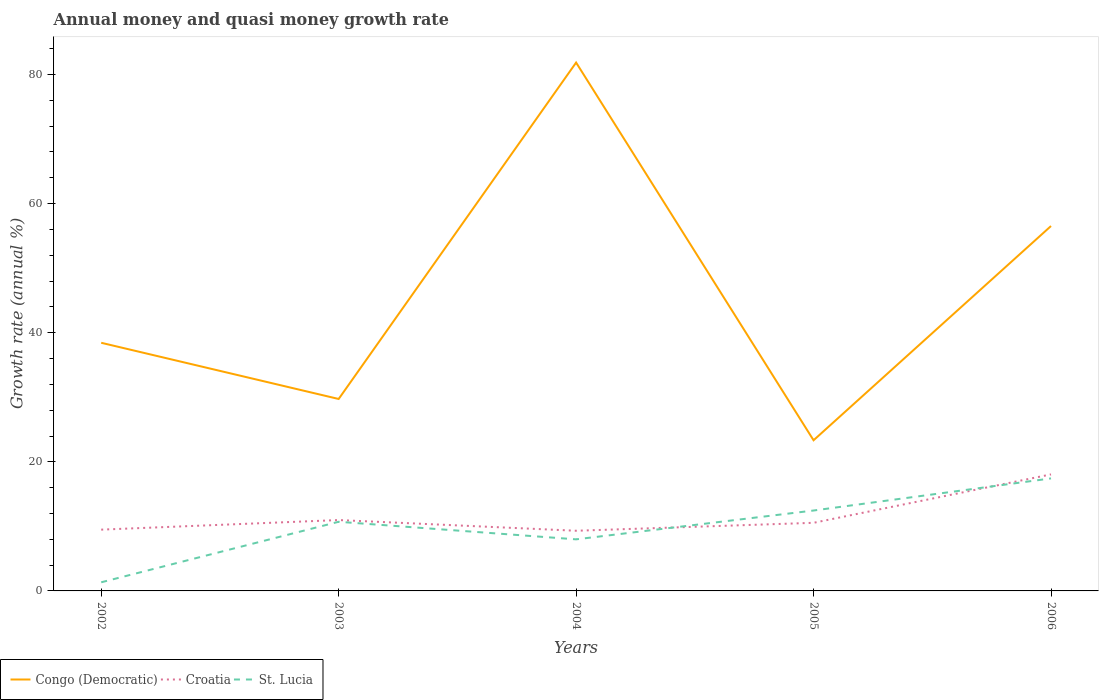How many different coloured lines are there?
Provide a short and direct response. 3. Does the line corresponding to Congo (Democratic) intersect with the line corresponding to St. Lucia?
Ensure brevity in your answer.  No. Is the number of lines equal to the number of legend labels?
Your answer should be compact. Yes. Across all years, what is the maximum growth rate in Croatia?
Offer a very short reply. 9.32. In which year was the growth rate in Congo (Democratic) maximum?
Provide a succinct answer. 2005. What is the total growth rate in St. Lucia in the graph?
Provide a short and direct response. 2.72. What is the difference between the highest and the second highest growth rate in Congo (Democratic)?
Provide a succinct answer. 58.51. What is the difference between the highest and the lowest growth rate in Congo (Democratic)?
Give a very brief answer. 2. Is the growth rate in Congo (Democratic) strictly greater than the growth rate in Croatia over the years?
Offer a terse response. No. What is the difference between two consecutive major ticks on the Y-axis?
Your answer should be compact. 20. Does the graph contain grids?
Keep it short and to the point. No. How many legend labels are there?
Your response must be concise. 3. How are the legend labels stacked?
Offer a very short reply. Horizontal. What is the title of the graph?
Your response must be concise. Annual money and quasi money growth rate. What is the label or title of the X-axis?
Keep it short and to the point. Years. What is the label or title of the Y-axis?
Give a very brief answer. Growth rate (annual %). What is the Growth rate (annual %) of Congo (Democratic) in 2002?
Your answer should be compact. 38.44. What is the Growth rate (annual %) in Croatia in 2002?
Make the answer very short. 9.49. What is the Growth rate (annual %) of St. Lucia in 2002?
Your response must be concise. 1.34. What is the Growth rate (annual %) in Congo (Democratic) in 2003?
Keep it short and to the point. 29.74. What is the Growth rate (annual %) of Croatia in 2003?
Your answer should be compact. 10.98. What is the Growth rate (annual %) in St. Lucia in 2003?
Keep it short and to the point. 10.71. What is the Growth rate (annual %) of Congo (Democratic) in 2004?
Make the answer very short. 81.85. What is the Growth rate (annual %) of Croatia in 2004?
Make the answer very short. 9.32. What is the Growth rate (annual %) of St. Lucia in 2004?
Your response must be concise. 7.99. What is the Growth rate (annual %) in Congo (Democratic) in 2005?
Your answer should be very brief. 23.34. What is the Growth rate (annual %) of Croatia in 2005?
Offer a very short reply. 10.55. What is the Growth rate (annual %) in St. Lucia in 2005?
Make the answer very short. 12.46. What is the Growth rate (annual %) of Congo (Democratic) in 2006?
Offer a terse response. 56.53. What is the Growth rate (annual %) in Croatia in 2006?
Your answer should be very brief. 18.05. What is the Growth rate (annual %) in St. Lucia in 2006?
Your answer should be very brief. 17.43. Across all years, what is the maximum Growth rate (annual %) in Congo (Democratic)?
Give a very brief answer. 81.85. Across all years, what is the maximum Growth rate (annual %) in Croatia?
Make the answer very short. 18.05. Across all years, what is the maximum Growth rate (annual %) in St. Lucia?
Keep it short and to the point. 17.43. Across all years, what is the minimum Growth rate (annual %) of Congo (Democratic)?
Make the answer very short. 23.34. Across all years, what is the minimum Growth rate (annual %) of Croatia?
Offer a terse response. 9.32. Across all years, what is the minimum Growth rate (annual %) in St. Lucia?
Make the answer very short. 1.34. What is the total Growth rate (annual %) of Congo (Democratic) in the graph?
Ensure brevity in your answer.  229.9. What is the total Growth rate (annual %) in Croatia in the graph?
Offer a very short reply. 58.4. What is the total Growth rate (annual %) in St. Lucia in the graph?
Make the answer very short. 49.93. What is the difference between the Growth rate (annual %) in Congo (Democratic) in 2002 and that in 2003?
Your response must be concise. 8.71. What is the difference between the Growth rate (annual %) in Croatia in 2002 and that in 2003?
Your answer should be very brief. -1.49. What is the difference between the Growth rate (annual %) in St. Lucia in 2002 and that in 2003?
Provide a short and direct response. -9.38. What is the difference between the Growth rate (annual %) in Congo (Democratic) in 2002 and that in 2004?
Offer a very short reply. -43.41. What is the difference between the Growth rate (annual %) in Croatia in 2002 and that in 2004?
Offer a terse response. 0.17. What is the difference between the Growth rate (annual %) in St. Lucia in 2002 and that in 2004?
Offer a terse response. -6.65. What is the difference between the Growth rate (annual %) in Congo (Democratic) in 2002 and that in 2005?
Offer a very short reply. 15.1. What is the difference between the Growth rate (annual %) in Croatia in 2002 and that in 2005?
Make the answer very short. -1.06. What is the difference between the Growth rate (annual %) of St. Lucia in 2002 and that in 2005?
Give a very brief answer. -11.12. What is the difference between the Growth rate (annual %) in Congo (Democratic) in 2002 and that in 2006?
Make the answer very short. -18.09. What is the difference between the Growth rate (annual %) in Croatia in 2002 and that in 2006?
Provide a succinct answer. -8.56. What is the difference between the Growth rate (annual %) of St. Lucia in 2002 and that in 2006?
Provide a short and direct response. -16.1. What is the difference between the Growth rate (annual %) in Congo (Democratic) in 2003 and that in 2004?
Make the answer very short. -52.12. What is the difference between the Growth rate (annual %) in Croatia in 2003 and that in 2004?
Offer a terse response. 1.66. What is the difference between the Growth rate (annual %) in St. Lucia in 2003 and that in 2004?
Your answer should be compact. 2.72. What is the difference between the Growth rate (annual %) in Congo (Democratic) in 2003 and that in 2005?
Keep it short and to the point. 6.39. What is the difference between the Growth rate (annual %) of Croatia in 2003 and that in 2005?
Give a very brief answer. 0.43. What is the difference between the Growth rate (annual %) of St. Lucia in 2003 and that in 2005?
Provide a short and direct response. -1.74. What is the difference between the Growth rate (annual %) of Congo (Democratic) in 2003 and that in 2006?
Provide a short and direct response. -26.79. What is the difference between the Growth rate (annual %) in Croatia in 2003 and that in 2006?
Give a very brief answer. -7.07. What is the difference between the Growth rate (annual %) in St. Lucia in 2003 and that in 2006?
Your answer should be compact. -6.72. What is the difference between the Growth rate (annual %) in Congo (Democratic) in 2004 and that in 2005?
Your answer should be compact. 58.51. What is the difference between the Growth rate (annual %) in Croatia in 2004 and that in 2005?
Your answer should be very brief. -1.23. What is the difference between the Growth rate (annual %) of St. Lucia in 2004 and that in 2005?
Give a very brief answer. -4.47. What is the difference between the Growth rate (annual %) in Congo (Democratic) in 2004 and that in 2006?
Give a very brief answer. 25.32. What is the difference between the Growth rate (annual %) in Croatia in 2004 and that in 2006?
Offer a very short reply. -8.73. What is the difference between the Growth rate (annual %) in St. Lucia in 2004 and that in 2006?
Your answer should be very brief. -9.44. What is the difference between the Growth rate (annual %) of Congo (Democratic) in 2005 and that in 2006?
Make the answer very short. -33.19. What is the difference between the Growth rate (annual %) in Croatia in 2005 and that in 2006?
Your response must be concise. -7.5. What is the difference between the Growth rate (annual %) in St. Lucia in 2005 and that in 2006?
Offer a very short reply. -4.98. What is the difference between the Growth rate (annual %) in Congo (Democratic) in 2002 and the Growth rate (annual %) in Croatia in 2003?
Provide a succinct answer. 27.46. What is the difference between the Growth rate (annual %) in Congo (Democratic) in 2002 and the Growth rate (annual %) in St. Lucia in 2003?
Your response must be concise. 27.73. What is the difference between the Growth rate (annual %) of Croatia in 2002 and the Growth rate (annual %) of St. Lucia in 2003?
Your answer should be very brief. -1.22. What is the difference between the Growth rate (annual %) of Congo (Democratic) in 2002 and the Growth rate (annual %) of Croatia in 2004?
Ensure brevity in your answer.  29.12. What is the difference between the Growth rate (annual %) in Congo (Democratic) in 2002 and the Growth rate (annual %) in St. Lucia in 2004?
Give a very brief answer. 30.45. What is the difference between the Growth rate (annual %) of Croatia in 2002 and the Growth rate (annual %) of St. Lucia in 2004?
Ensure brevity in your answer.  1.5. What is the difference between the Growth rate (annual %) in Congo (Democratic) in 2002 and the Growth rate (annual %) in Croatia in 2005?
Make the answer very short. 27.89. What is the difference between the Growth rate (annual %) of Congo (Democratic) in 2002 and the Growth rate (annual %) of St. Lucia in 2005?
Ensure brevity in your answer.  25.99. What is the difference between the Growth rate (annual %) of Croatia in 2002 and the Growth rate (annual %) of St. Lucia in 2005?
Keep it short and to the point. -2.96. What is the difference between the Growth rate (annual %) in Congo (Democratic) in 2002 and the Growth rate (annual %) in Croatia in 2006?
Your answer should be very brief. 20.39. What is the difference between the Growth rate (annual %) of Congo (Democratic) in 2002 and the Growth rate (annual %) of St. Lucia in 2006?
Provide a succinct answer. 21.01. What is the difference between the Growth rate (annual %) in Croatia in 2002 and the Growth rate (annual %) in St. Lucia in 2006?
Your response must be concise. -7.94. What is the difference between the Growth rate (annual %) of Congo (Democratic) in 2003 and the Growth rate (annual %) of Croatia in 2004?
Keep it short and to the point. 20.41. What is the difference between the Growth rate (annual %) of Congo (Democratic) in 2003 and the Growth rate (annual %) of St. Lucia in 2004?
Ensure brevity in your answer.  21.75. What is the difference between the Growth rate (annual %) of Croatia in 2003 and the Growth rate (annual %) of St. Lucia in 2004?
Provide a short and direct response. 2.99. What is the difference between the Growth rate (annual %) in Congo (Democratic) in 2003 and the Growth rate (annual %) in Croatia in 2005?
Offer a terse response. 19.18. What is the difference between the Growth rate (annual %) in Congo (Democratic) in 2003 and the Growth rate (annual %) in St. Lucia in 2005?
Your answer should be very brief. 17.28. What is the difference between the Growth rate (annual %) in Croatia in 2003 and the Growth rate (annual %) in St. Lucia in 2005?
Your answer should be very brief. -1.48. What is the difference between the Growth rate (annual %) of Congo (Democratic) in 2003 and the Growth rate (annual %) of Croatia in 2006?
Ensure brevity in your answer.  11.68. What is the difference between the Growth rate (annual %) in Congo (Democratic) in 2003 and the Growth rate (annual %) in St. Lucia in 2006?
Make the answer very short. 12.3. What is the difference between the Growth rate (annual %) in Croatia in 2003 and the Growth rate (annual %) in St. Lucia in 2006?
Keep it short and to the point. -6.45. What is the difference between the Growth rate (annual %) in Congo (Democratic) in 2004 and the Growth rate (annual %) in Croatia in 2005?
Make the answer very short. 71.3. What is the difference between the Growth rate (annual %) in Congo (Democratic) in 2004 and the Growth rate (annual %) in St. Lucia in 2005?
Offer a very short reply. 69.4. What is the difference between the Growth rate (annual %) of Croatia in 2004 and the Growth rate (annual %) of St. Lucia in 2005?
Offer a terse response. -3.13. What is the difference between the Growth rate (annual %) in Congo (Democratic) in 2004 and the Growth rate (annual %) in Croatia in 2006?
Your answer should be very brief. 63.8. What is the difference between the Growth rate (annual %) of Congo (Democratic) in 2004 and the Growth rate (annual %) of St. Lucia in 2006?
Offer a terse response. 64.42. What is the difference between the Growth rate (annual %) in Croatia in 2004 and the Growth rate (annual %) in St. Lucia in 2006?
Make the answer very short. -8.11. What is the difference between the Growth rate (annual %) of Congo (Democratic) in 2005 and the Growth rate (annual %) of Croatia in 2006?
Your answer should be compact. 5.29. What is the difference between the Growth rate (annual %) in Congo (Democratic) in 2005 and the Growth rate (annual %) in St. Lucia in 2006?
Provide a short and direct response. 5.91. What is the difference between the Growth rate (annual %) in Croatia in 2005 and the Growth rate (annual %) in St. Lucia in 2006?
Give a very brief answer. -6.88. What is the average Growth rate (annual %) in Congo (Democratic) per year?
Offer a very short reply. 45.98. What is the average Growth rate (annual %) of Croatia per year?
Make the answer very short. 11.68. What is the average Growth rate (annual %) in St. Lucia per year?
Keep it short and to the point. 9.99. In the year 2002, what is the difference between the Growth rate (annual %) in Congo (Democratic) and Growth rate (annual %) in Croatia?
Your answer should be compact. 28.95. In the year 2002, what is the difference between the Growth rate (annual %) of Congo (Democratic) and Growth rate (annual %) of St. Lucia?
Your answer should be compact. 37.11. In the year 2002, what is the difference between the Growth rate (annual %) of Croatia and Growth rate (annual %) of St. Lucia?
Keep it short and to the point. 8.16. In the year 2003, what is the difference between the Growth rate (annual %) of Congo (Democratic) and Growth rate (annual %) of Croatia?
Offer a terse response. 18.76. In the year 2003, what is the difference between the Growth rate (annual %) in Congo (Democratic) and Growth rate (annual %) in St. Lucia?
Give a very brief answer. 19.02. In the year 2003, what is the difference between the Growth rate (annual %) in Croatia and Growth rate (annual %) in St. Lucia?
Offer a terse response. 0.27. In the year 2004, what is the difference between the Growth rate (annual %) in Congo (Democratic) and Growth rate (annual %) in Croatia?
Your response must be concise. 72.53. In the year 2004, what is the difference between the Growth rate (annual %) in Congo (Democratic) and Growth rate (annual %) in St. Lucia?
Your response must be concise. 73.86. In the year 2004, what is the difference between the Growth rate (annual %) in Croatia and Growth rate (annual %) in St. Lucia?
Keep it short and to the point. 1.33. In the year 2005, what is the difference between the Growth rate (annual %) of Congo (Democratic) and Growth rate (annual %) of Croatia?
Your response must be concise. 12.79. In the year 2005, what is the difference between the Growth rate (annual %) in Congo (Democratic) and Growth rate (annual %) in St. Lucia?
Offer a very short reply. 10.88. In the year 2005, what is the difference between the Growth rate (annual %) in Croatia and Growth rate (annual %) in St. Lucia?
Keep it short and to the point. -1.9. In the year 2006, what is the difference between the Growth rate (annual %) in Congo (Democratic) and Growth rate (annual %) in Croatia?
Your answer should be very brief. 38.48. In the year 2006, what is the difference between the Growth rate (annual %) in Congo (Democratic) and Growth rate (annual %) in St. Lucia?
Make the answer very short. 39.1. In the year 2006, what is the difference between the Growth rate (annual %) of Croatia and Growth rate (annual %) of St. Lucia?
Keep it short and to the point. 0.62. What is the ratio of the Growth rate (annual %) in Congo (Democratic) in 2002 to that in 2003?
Provide a short and direct response. 1.29. What is the ratio of the Growth rate (annual %) of Croatia in 2002 to that in 2003?
Give a very brief answer. 0.86. What is the ratio of the Growth rate (annual %) in St. Lucia in 2002 to that in 2003?
Your answer should be very brief. 0.12. What is the ratio of the Growth rate (annual %) in Congo (Democratic) in 2002 to that in 2004?
Offer a very short reply. 0.47. What is the ratio of the Growth rate (annual %) of Croatia in 2002 to that in 2004?
Provide a succinct answer. 1.02. What is the ratio of the Growth rate (annual %) of St. Lucia in 2002 to that in 2004?
Provide a succinct answer. 0.17. What is the ratio of the Growth rate (annual %) of Congo (Democratic) in 2002 to that in 2005?
Your answer should be very brief. 1.65. What is the ratio of the Growth rate (annual %) in Croatia in 2002 to that in 2005?
Your answer should be very brief. 0.9. What is the ratio of the Growth rate (annual %) of St. Lucia in 2002 to that in 2005?
Your response must be concise. 0.11. What is the ratio of the Growth rate (annual %) of Congo (Democratic) in 2002 to that in 2006?
Your answer should be very brief. 0.68. What is the ratio of the Growth rate (annual %) of Croatia in 2002 to that in 2006?
Your answer should be very brief. 0.53. What is the ratio of the Growth rate (annual %) of St. Lucia in 2002 to that in 2006?
Ensure brevity in your answer.  0.08. What is the ratio of the Growth rate (annual %) of Congo (Democratic) in 2003 to that in 2004?
Offer a terse response. 0.36. What is the ratio of the Growth rate (annual %) of Croatia in 2003 to that in 2004?
Keep it short and to the point. 1.18. What is the ratio of the Growth rate (annual %) in St. Lucia in 2003 to that in 2004?
Ensure brevity in your answer.  1.34. What is the ratio of the Growth rate (annual %) in Congo (Democratic) in 2003 to that in 2005?
Offer a terse response. 1.27. What is the ratio of the Growth rate (annual %) of Croatia in 2003 to that in 2005?
Give a very brief answer. 1.04. What is the ratio of the Growth rate (annual %) of St. Lucia in 2003 to that in 2005?
Offer a very short reply. 0.86. What is the ratio of the Growth rate (annual %) of Congo (Democratic) in 2003 to that in 2006?
Make the answer very short. 0.53. What is the ratio of the Growth rate (annual %) of Croatia in 2003 to that in 2006?
Your response must be concise. 0.61. What is the ratio of the Growth rate (annual %) in St. Lucia in 2003 to that in 2006?
Ensure brevity in your answer.  0.61. What is the ratio of the Growth rate (annual %) in Congo (Democratic) in 2004 to that in 2005?
Keep it short and to the point. 3.51. What is the ratio of the Growth rate (annual %) of Croatia in 2004 to that in 2005?
Keep it short and to the point. 0.88. What is the ratio of the Growth rate (annual %) of St. Lucia in 2004 to that in 2005?
Give a very brief answer. 0.64. What is the ratio of the Growth rate (annual %) in Congo (Democratic) in 2004 to that in 2006?
Your answer should be very brief. 1.45. What is the ratio of the Growth rate (annual %) of Croatia in 2004 to that in 2006?
Offer a very short reply. 0.52. What is the ratio of the Growth rate (annual %) of St. Lucia in 2004 to that in 2006?
Provide a succinct answer. 0.46. What is the ratio of the Growth rate (annual %) in Congo (Democratic) in 2005 to that in 2006?
Provide a short and direct response. 0.41. What is the ratio of the Growth rate (annual %) in Croatia in 2005 to that in 2006?
Make the answer very short. 0.58. What is the ratio of the Growth rate (annual %) in St. Lucia in 2005 to that in 2006?
Your answer should be compact. 0.71. What is the difference between the highest and the second highest Growth rate (annual %) of Congo (Democratic)?
Provide a succinct answer. 25.32. What is the difference between the highest and the second highest Growth rate (annual %) of Croatia?
Make the answer very short. 7.07. What is the difference between the highest and the second highest Growth rate (annual %) of St. Lucia?
Provide a short and direct response. 4.98. What is the difference between the highest and the lowest Growth rate (annual %) of Congo (Democratic)?
Ensure brevity in your answer.  58.51. What is the difference between the highest and the lowest Growth rate (annual %) of Croatia?
Keep it short and to the point. 8.73. What is the difference between the highest and the lowest Growth rate (annual %) of St. Lucia?
Your answer should be compact. 16.1. 